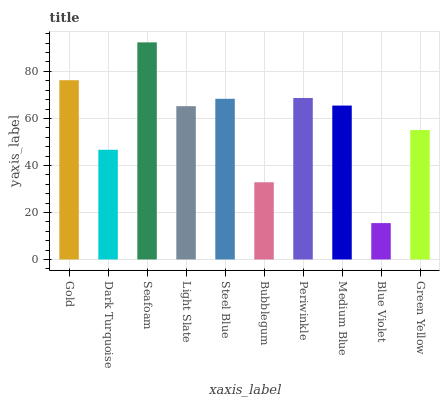Is Blue Violet the minimum?
Answer yes or no. Yes. Is Seafoam the maximum?
Answer yes or no. Yes. Is Dark Turquoise the minimum?
Answer yes or no. No. Is Dark Turquoise the maximum?
Answer yes or no. No. Is Gold greater than Dark Turquoise?
Answer yes or no. Yes. Is Dark Turquoise less than Gold?
Answer yes or no. Yes. Is Dark Turquoise greater than Gold?
Answer yes or no. No. Is Gold less than Dark Turquoise?
Answer yes or no. No. Is Medium Blue the high median?
Answer yes or no. Yes. Is Light Slate the low median?
Answer yes or no. Yes. Is Bubblegum the high median?
Answer yes or no. No. Is Periwinkle the low median?
Answer yes or no. No. 